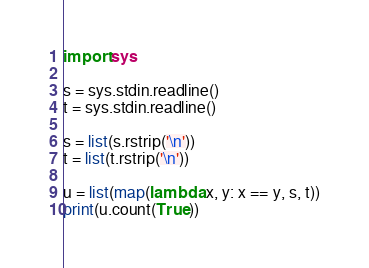Convert code to text. <code><loc_0><loc_0><loc_500><loc_500><_Python_>import sys

s = sys.stdin.readline()
t = sys.stdin.readline()

s = list(s.rstrip('\n'))
t = list(t.rstrip('\n'))

u = list(map(lambda x, y: x == y, s, t))
print(u.count(True))
</code> 